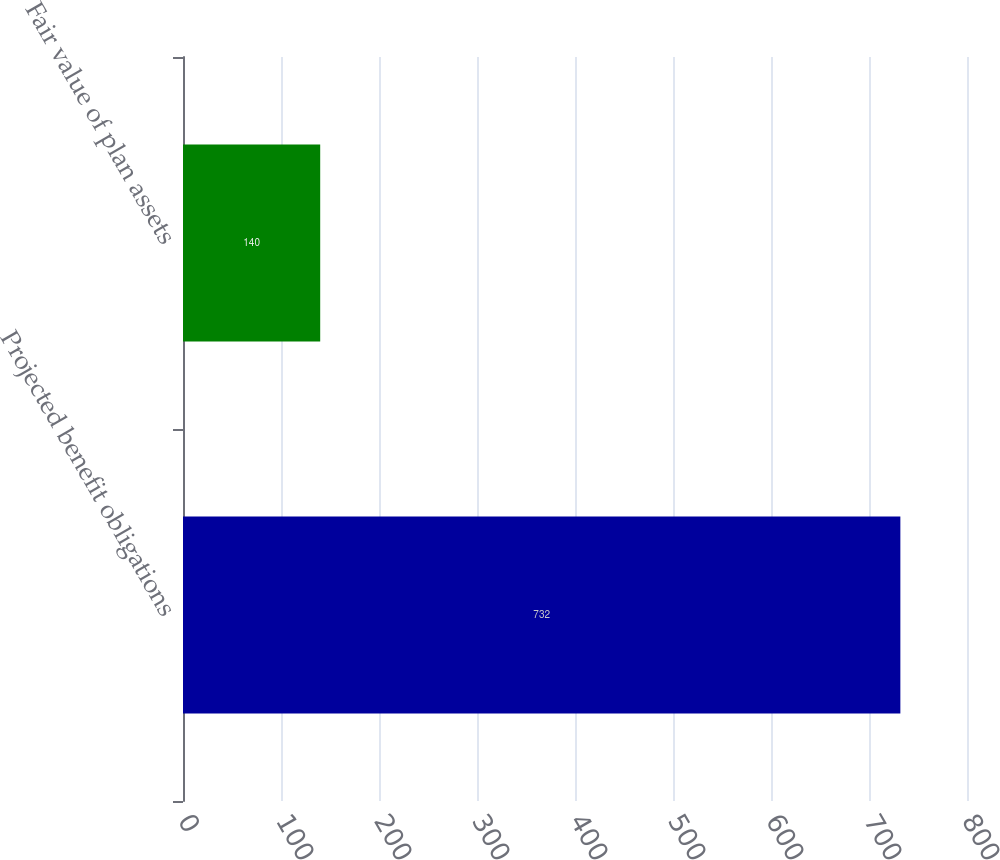Convert chart. <chart><loc_0><loc_0><loc_500><loc_500><bar_chart><fcel>Projected benefit obligations<fcel>Fair value of plan assets<nl><fcel>732<fcel>140<nl></chart> 